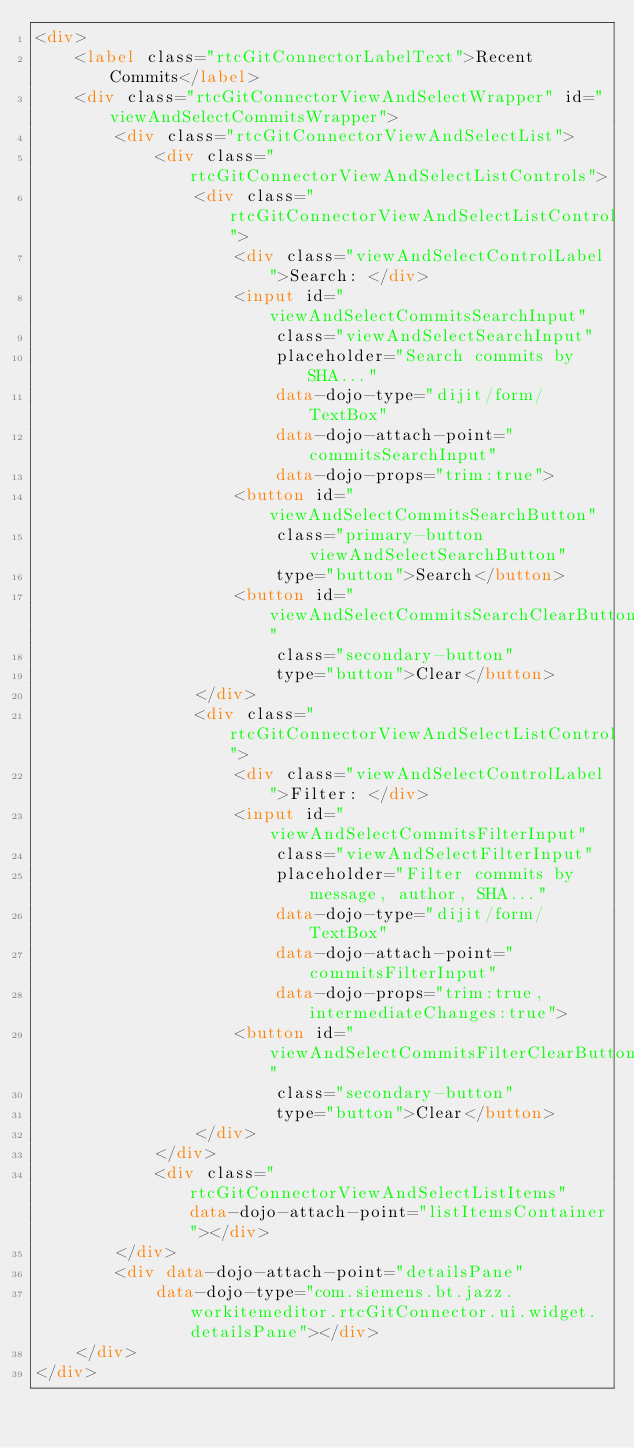Convert code to text. <code><loc_0><loc_0><loc_500><loc_500><_HTML_><div>
    <label class="rtcGitConnectorLabelText">Recent Commits</label>
    <div class="rtcGitConnectorViewAndSelectWrapper" id="viewAndSelectCommitsWrapper">
        <div class="rtcGitConnectorViewAndSelectList">
            <div class="rtcGitConnectorViewAndSelectListControls">
                <div class="rtcGitConnectorViewAndSelectListControl">
                    <div class="viewAndSelectControlLabel">Search: </div>
                    <input id="viewAndSelectCommitsSearchInput"
                        class="viewAndSelectSearchInput"
                        placeholder="Search commits by SHA..."
                        data-dojo-type="dijit/form/TextBox"
                        data-dojo-attach-point="commitsSearchInput"
                        data-dojo-props="trim:true">
                    <button id="viewAndSelectCommitsSearchButton"
                        class="primary-button viewAndSelectSearchButton"
                        type="button">Search</button>
                    <button id="viewAndSelectCommitsSearchClearButton"
                        class="secondary-button"
                        type="button">Clear</button>
                </div>
                <div class="rtcGitConnectorViewAndSelectListControl">
                    <div class="viewAndSelectControlLabel">Filter: </div>
                    <input id="viewAndSelectCommitsFilterInput"
                        class="viewAndSelectFilterInput"
                        placeholder="Filter commits by message, author, SHA..."
                        data-dojo-type="dijit/form/TextBox"
                        data-dojo-attach-point="commitsFilterInput"
                        data-dojo-props="trim:true, intermediateChanges:true">
                    <button id="viewAndSelectCommitsFilterClearButton"
                        class="secondary-button"
                        type="button">Clear</button>
                </div>
            </div>
            <div class="rtcGitConnectorViewAndSelectListItems" data-dojo-attach-point="listItemsContainer"></div>
        </div>
        <div data-dojo-attach-point="detailsPane"
            data-dojo-type="com.siemens.bt.jazz.workitemeditor.rtcGitConnector.ui.widget.detailsPane"></div>
    </div>
</div></code> 